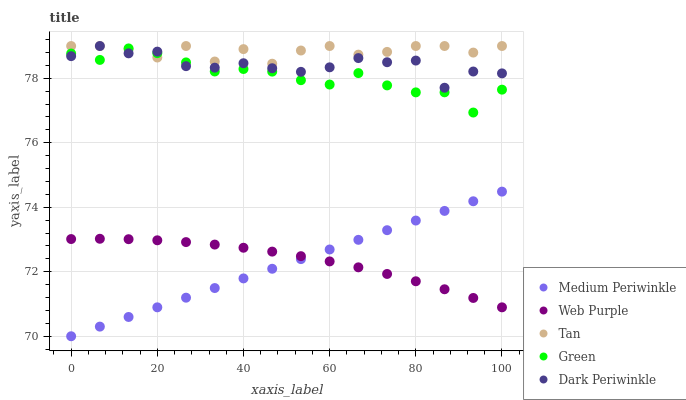Does Medium Periwinkle have the minimum area under the curve?
Answer yes or no. Yes. Does Tan have the maximum area under the curve?
Answer yes or no. Yes. Does Web Purple have the minimum area under the curve?
Answer yes or no. No. Does Web Purple have the maximum area under the curve?
Answer yes or no. No. Is Medium Periwinkle the smoothest?
Answer yes or no. Yes. Is Tan the roughest?
Answer yes or no. Yes. Is Web Purple the smoothest?
Answer yes or no. No. Is Web Purple the roughest?
Answer yes or no. No. Does Medium Periwinkle have the lowest value?
Answer yes or no. Yes. Does Web Purple have the lowest value?
Answer yes or no. No. Does Dark Periwinkle have the highest value?
Answer yes or no. Yes. Does Medium Periwinkle have the highest value?
Answer yes or no. No. Is Medium Periwinkle less than Dark Periwinkle?
Answer yes or no. Yes. Is Tan greater than Web Purple?
Answer yes or no. Yes. Does Dark Periwinkle intersect Green?
Answer yes or no. Yes. Is Dark Periwinkle less than Green?
Answer yes or no. No. Is Dark Periwinkle greater than Green?
Answer yes or no. No. Does Medium Periwinkle intersect Dark Periwinkle?
Answer yes or no. No. 